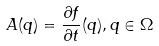Convert formula to latex. <formula><loc_0><loc_0><loc_500><loc_500>A ( q ) = \frac { \partial f } { \partial t } ( q ) , q \in \Omega</formula> 